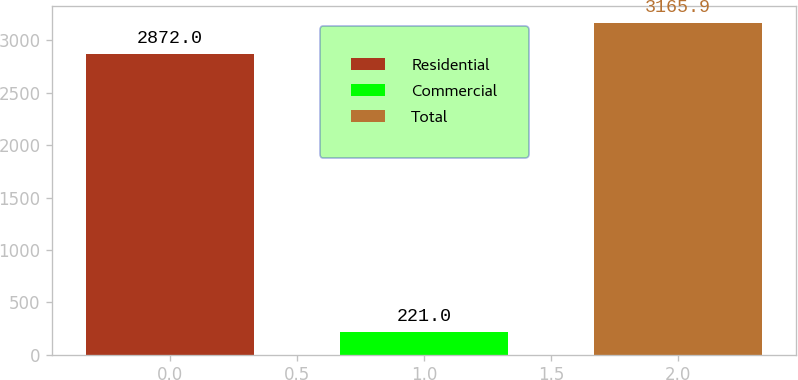<chart> <loc_0><loc_0><loc_500><loc_500><bar_chart><fcel>Residential<fcel>Commercial<fcel>Total<nl><fcel>2872<fcel>221<fcel>3165.9<nl></chart> 